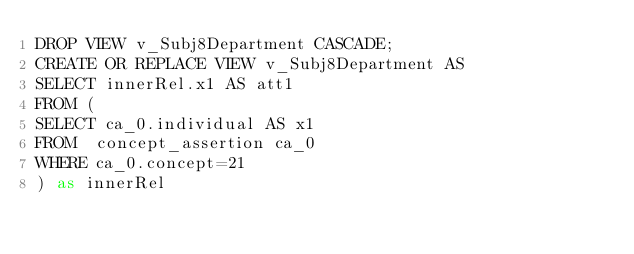<code> <loc_0><loc_0><loc_500><loc_500><_SQL_>DROP VIEW v_Subj8Department CASCADE;
CREATE OR REPLACE VIEW v_Subj8Department AS 
SELECT innerRel.x1 AS att1
FROM (
SELECT ca_0.individual AS x1
FROM  concept_assertion ca_0
WHERE ca_0.concept=21
) as innerRel
</code> 